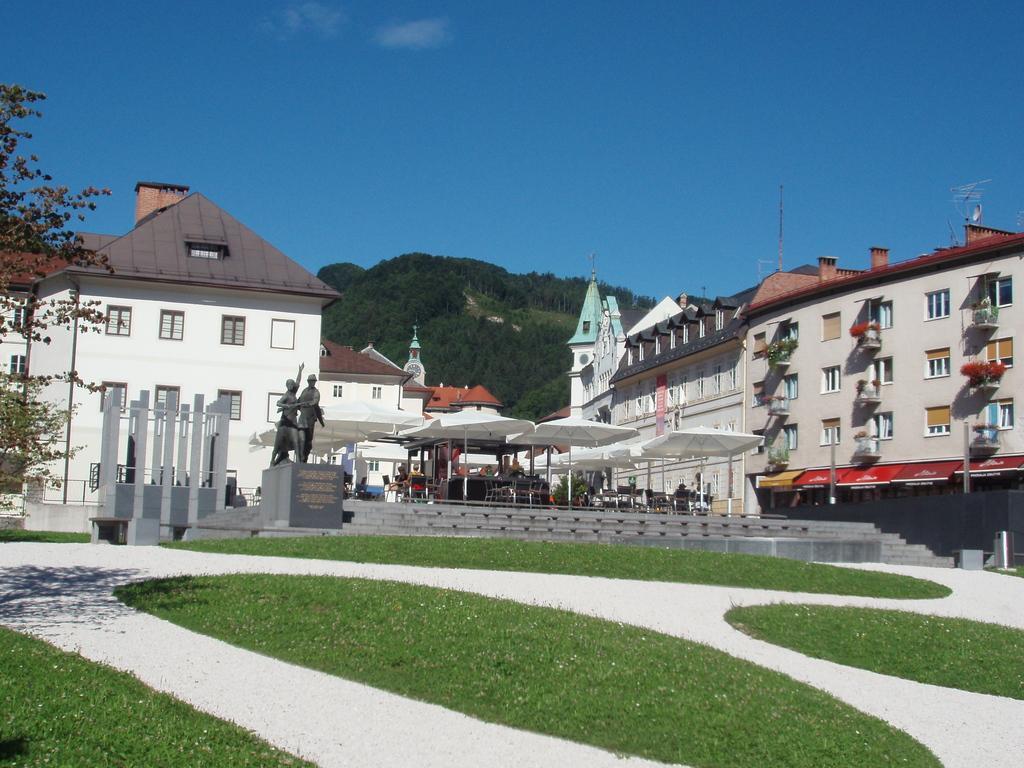How would you summarize this image in a sentence or two? This picture is clicked outside. In the foreground we can see the ground and the green grass and we can see the sculptures of two persons. In the center we can see the buildings, windows of the buildings and we can see the tents, group of people, chairs and the stairs and many other objects. In the background we can see the sky, trees and some other items. 